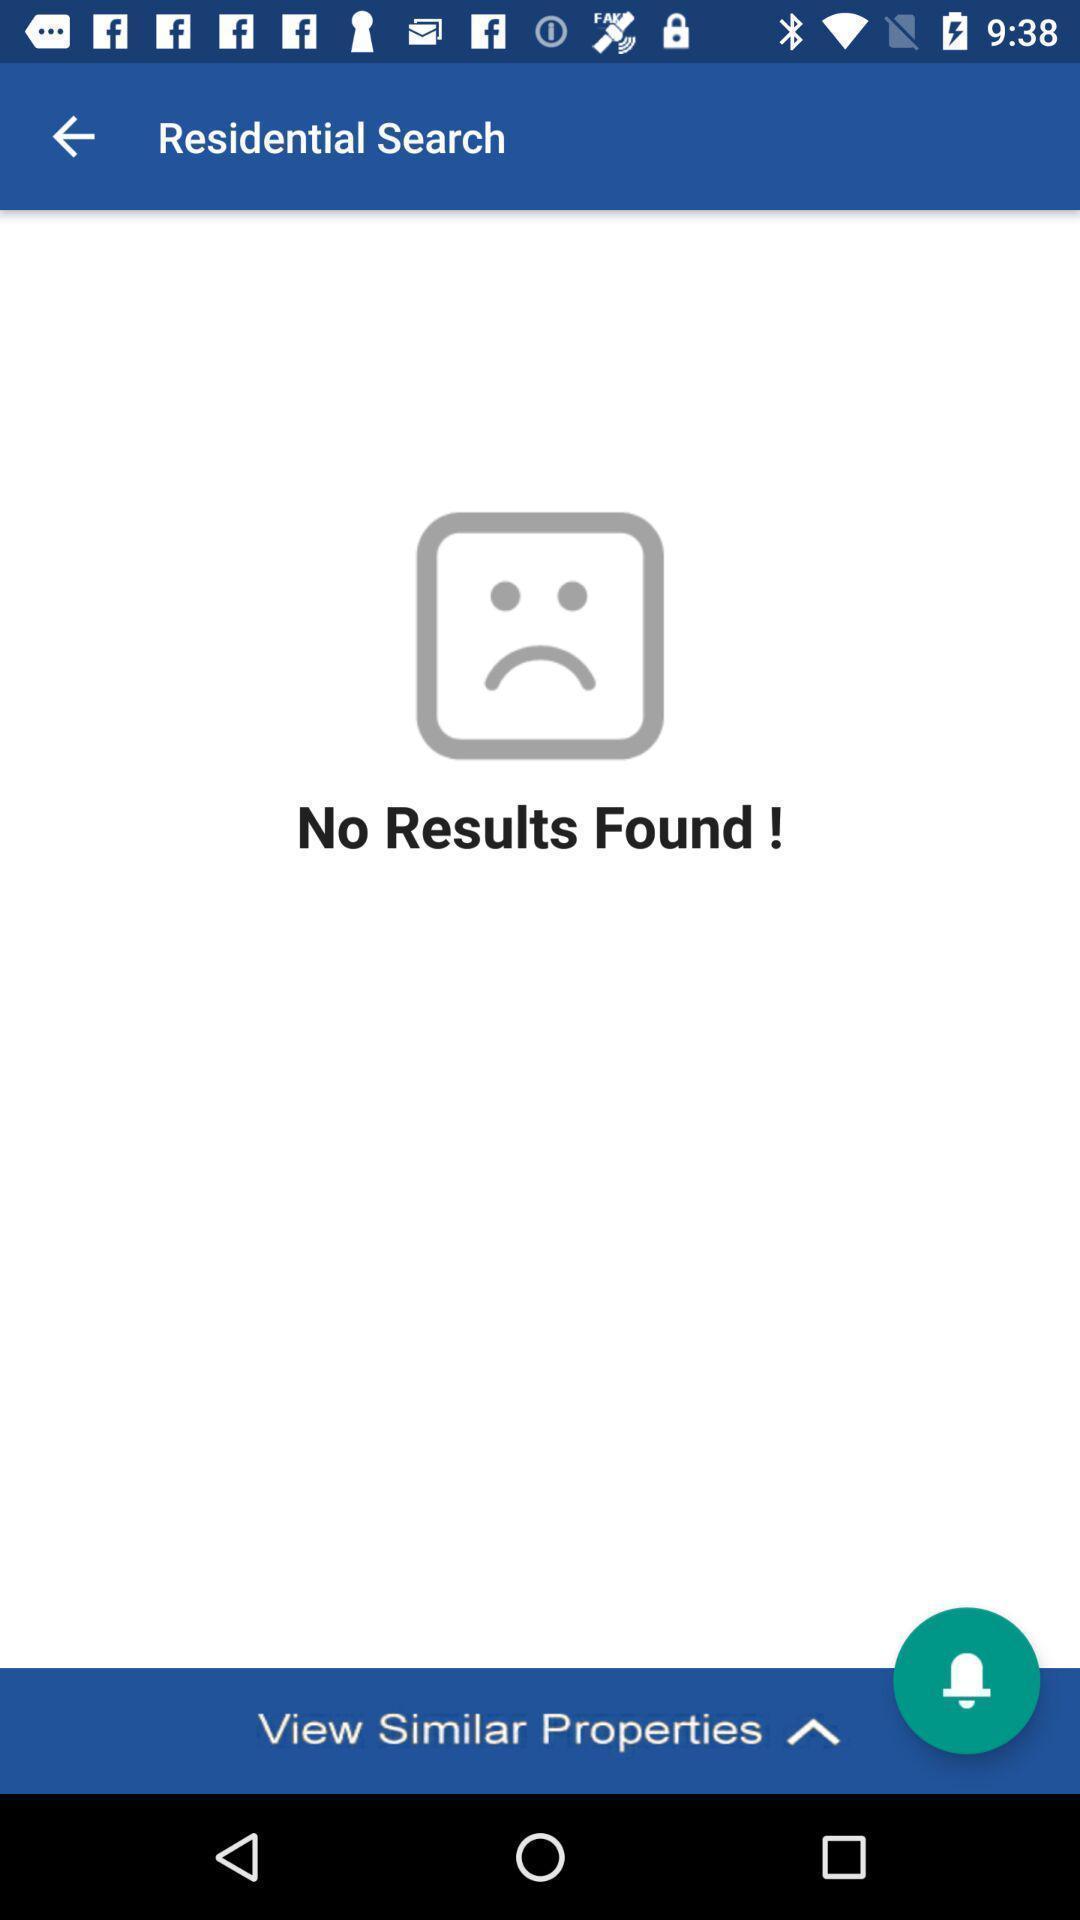Describe the content in this image. Page showing no results in property finding app. 